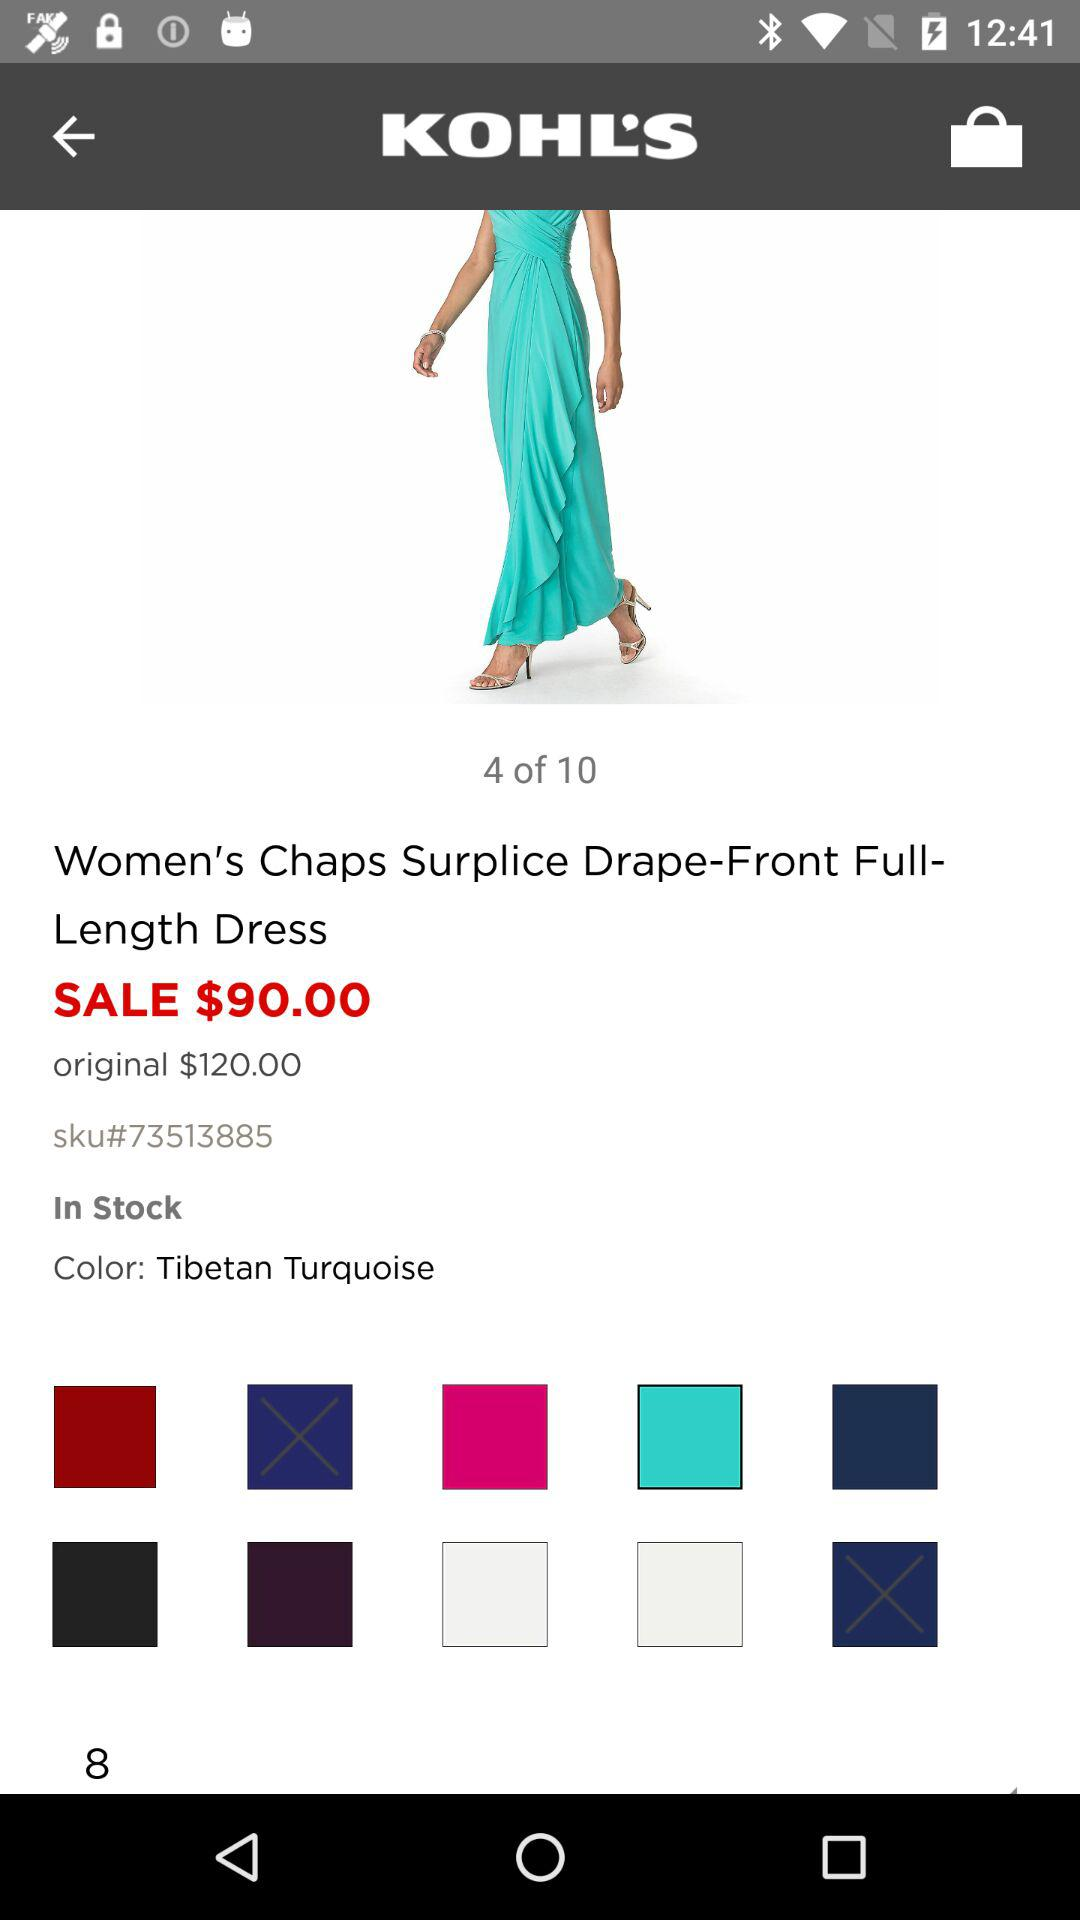What is the color of the dress? The color of the dress is Tibetan Turquoise. 